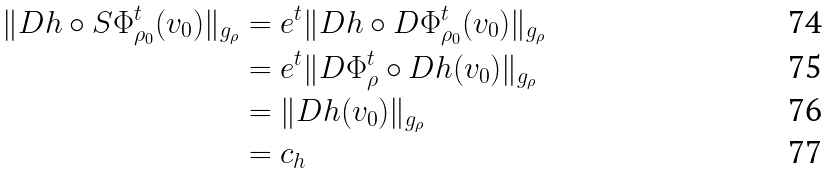Convert formula to latex. <formula><loc_0><loc_0><loc_500><loc_500>\| D h \circ S \Phi _ { \rho _ { 0 } } ^ { t } ( v _ { 0 } ) \| _ { g _ { \rho } } & = e ^ { t } \| D h \circ D \Phi _ { \rho _ { 0 } } ^ { t } ( v _ { 0 } ) \| _ { g _ { \rho } } \\ & = e ^ { t } \| D \Phi _ { \rho } ^ { t } \circ D h ( v _ { 0 } ) \| _ { g _ { \rho } } \\ & = \| D h ( v _ { 0 } ) \| _ { g _ { \rho } } \\ & = c _ { h }</formula> 